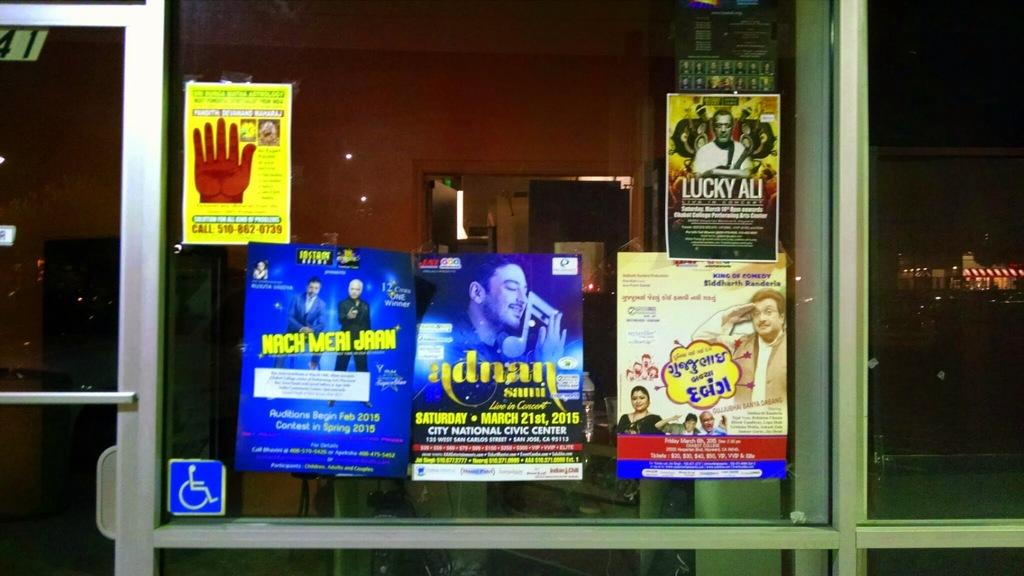<image>
Give a short and clear explanation of the subsequent image. a window to an establishment with several posters and a handicap accessible sign taped to it. 